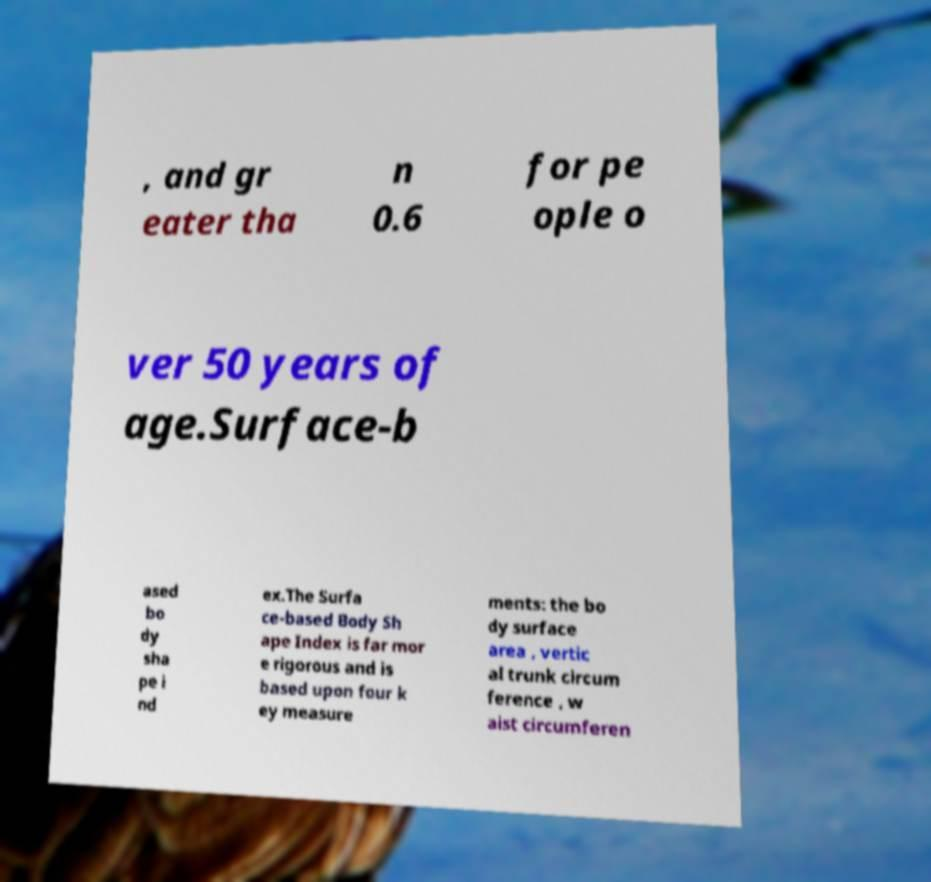Please identify and transcribe the text found in this image. , and gr eater tha n 0.6 for pe ople o ver 50 years of age.Surface-b ased bo dy sha pe i nd ex.The Surfa ce-based Body Sh ape Index is far mor e rigorous and is based upon four k ey measure ments: the bo dy surface area , vertic al trunk circum ference , w aist circumferen 